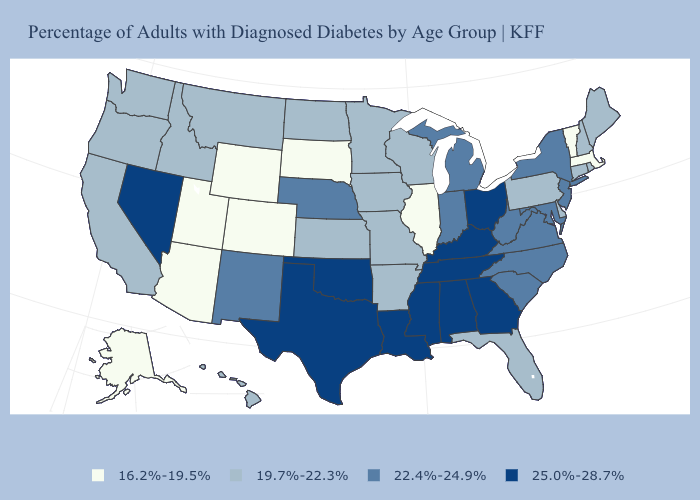Which states have the lowest value in the West?
Quick response, please. Alaska, Arizona, Colorado, Utah, Wyoming. Does Delaware have the lowest value in the South?
Answer briefly. Yes. Does the first symbol in the legend represent the smallest category?
Answer briefly. Yes. Which states hav the highest value in the West?
Keep it brief. Nevada. Name the states that have a value in the range 25.0%-28.7%?
Short answer required. Alabama, Georgia, Kentucky, Louisiana, Mississippi, Nevada, Ohio, Oklahoma, Tennessee, Texas. What is the value of Louisiana?
Answer briefly. 25.0%-28.7%. Does Iowa have the lowest value in the MidWest?
Give a very brief answer. No. Does South Dakota have the lowest value in the MidWest?
Be succinct. Yes. What is the value of Oregon?
Concise answer only. 19.7%-22.3%. Among the states that border Connecticut , which have the highest value?
Write a very short answer. New York. How many symbols are there in the legend?
Give a very brief answer. 4. Name the states that have a value in the range 19.7%-22.3%?
Be succinct. Arkansas, California, Connecticut, Delaware, Florida, Hawaii, Idaho, Iowa, Kansas, Maine, Minnesota, Missouri, Montana, New Hampshire, North Dakota, Oregon, Pennsylvania, Rhode Island, Washington, Wisconsin. What is the highest value in the Northeast ?
Answer briefly. 22.4%-24.9%. Does Ohio have the highest value in the MidWest?
Write a very short answer. Yes. 